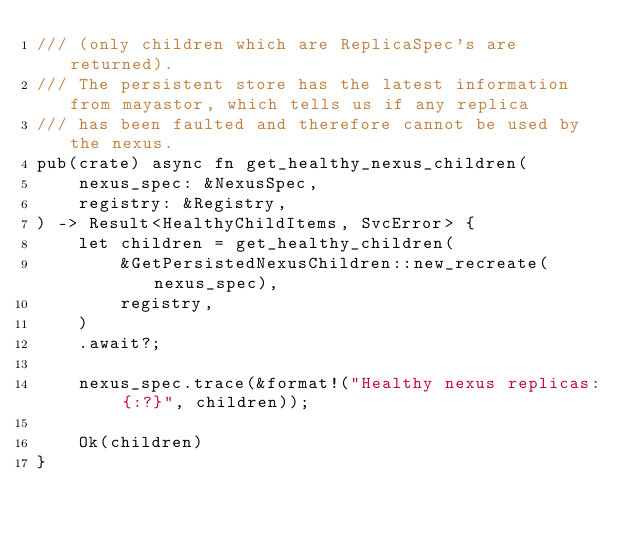Convert code to text. <code><loc_0><loc_0><loc_500><loc_500><_Rust_>/// (only children which are ReplicaSpec's are returned).
/// The persistent store has the latest information from mayastor, which tells us if any replica
/// has been faulted and therefore cannot be used by the nexus.
pub(crate) async fn get_healthy_nexus_children(
    nexus_spec: &NexusSpec,
    registry: &Registry,
) -> Result<HealthyChildItems, SvcError> {
    let children = get_healthy_children(
        &GetPersistedNexusChildren::new_recreate(nexus_spec),
        registry,
    )
    .await?;

    nexus_spec.trace(&format!("Healthy nexus replicas: {:?}", children));

    Ok(children)
}
</code> 